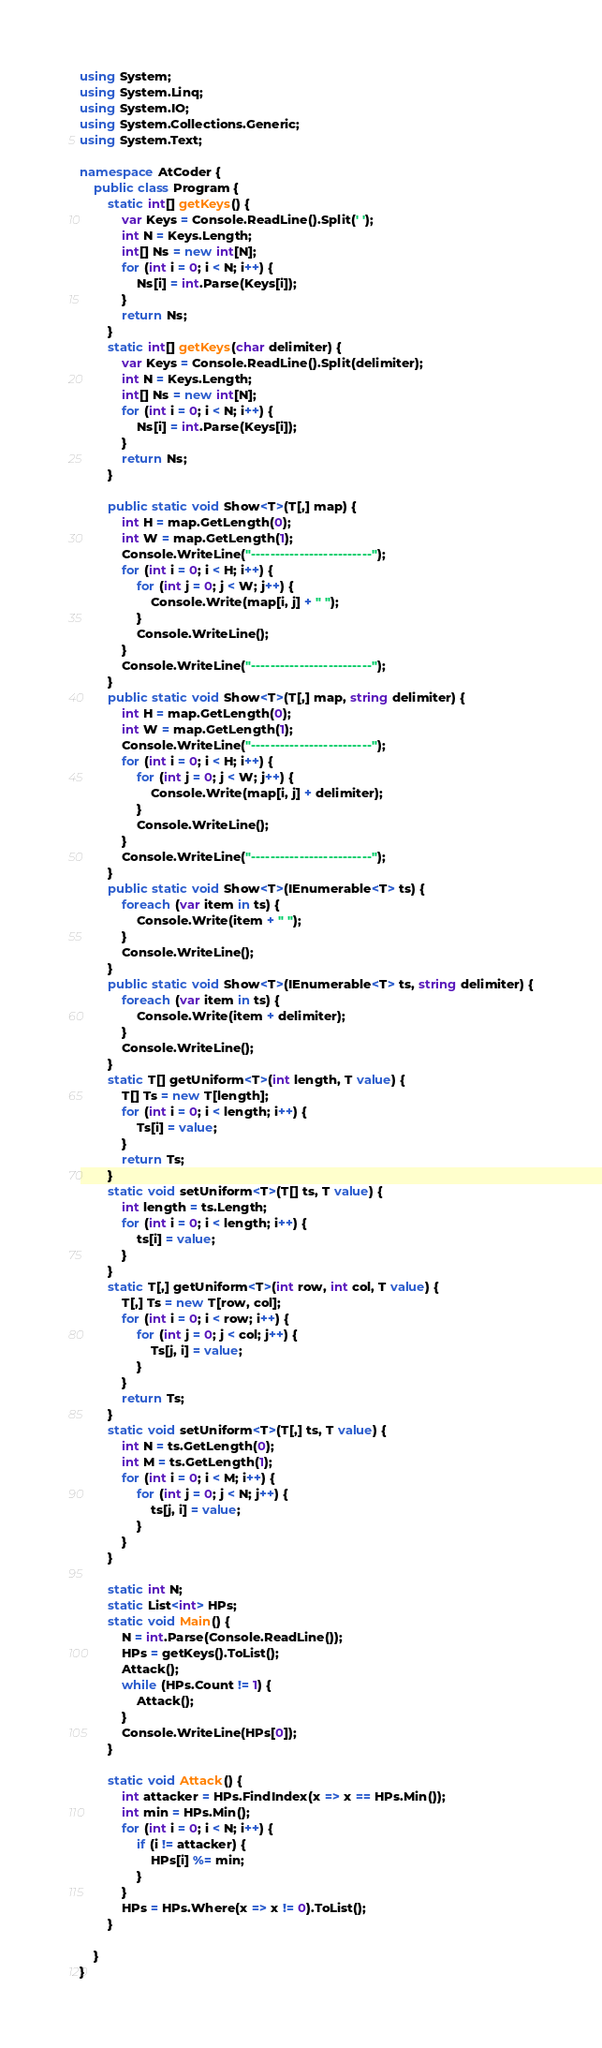<code> <loc_0><loc_0><loc_500><loc_500><_C#_>using System;
using System.Linq;
using System.IO;
using System.Collections.Generic;
using System.Text;

namespace AtCoder {
    public class Program {
        static int[] getKeys() {
            var Keys = Console.ReadLine().Split(' ');
            int N = Keys.Length;
            int[] Ns = new int[N];
            for (int i = 0; i < N; i++) {
                Ns[i] = int.Parse(Keys[i]);
            }
            return Ns;
        }
        static int[] getKeys(char delimiter) {
            var Keys = Console.ReadLine().Split(delimiter);
            int N = Keys.Length;
            int[] Ns = new int[N];
            for (int i = 0; i < N; i++) {
                Ns[i] = int.Parse(Keys[i]);
            }
            return Ns;
        }

        public static void Show<T>(T[,] map) {
            int H = map.GetLength(0);
            int W = map.GetLength(1);
            Console.WriteLine("-------------------------");
            for (int i = 0; i < H; i++) {
                for (int j = 0; j < W; j++) {
                    Console.Write(map[i, j] + " ");
                }
                Console.WriteLine();
            }
            Console.WriteLine("-------------------------");
        }
        public static void Show<T>(T[,] map, string delimiter) {
            int H = map.GetLength(0);
            int W = map.GetLength(1);
            Console.WriteLine("-------------------------");
            for (int i = 0; i < H; i++) {
                for (int j = 0; j < W; j++) {
                    Console.Write(map[i, j] + delimiter);
                }
                Console.WriteLine();
            }
            Console.WriteLine("-------------------------");
        }
        public static void Show<T>(IEnumerable<T> ts) {
            foreach (var item in ts) {
                Console.Write(item + " ");
            }
            Console.WriteLine();
        }
        public static void Show<T>(IEnumerable<T> ts, string delimiter) {
            foreach (var item in ts) {
                Console.Write(item + delimiter);
            }
            Console.WriteLine();
        }
        static T[] getUniform<T>(int length, T value) {
            T[] Ts = new T[length];
            for (int i = 0; i < length; i++) {
                Ts[i] = value;
            }
            return Ts;
        }
        static void setUniform<T>(T[] ts, T value) {
            int length = ts.Length;
            for (int i = 0; i < length; i++) {
                ts[i] = value;
            }
        }
        static T[,] getUniform<T>(int row, int col, T value) {
            T[,] Ts = new T[row, col];
            for (int i = 0; i < row; i++) {
                for (int j = 0; j < col; j++) {
                    Ts[j, i] = value;
                }
            }
            return Ts;
        }
        static void setUniform<T>(T[,] ts, T value) {
            int N = ts.GetLength(0);
            int M = ts.GetLength(1);
            for (int i = 0; i < M; i++) {
                for (int j = 0; j < N; j++) {
                    ts[j, i] = value;
                }
            }
        }

        static int N;
        static List<int> HPs;
        static void Main() {
            N = int.Parse(Console.ReadLine());
            HPs = getKeys().ToList();
            Attack();
            while (HPs.Count != 1) {
                Attack();
            }
            Console.WriteLine(HPs[0]);
        }

        static void Attack() {
            int attacker = HPs.FindIndex(x => x == HPs.Min());
            int min = HPs.Min();
            for (int i = 0; i < N; i++) {
                if (i != attacker) {
                    HPs[i] %= min;
                }
            }
            HPs = HPs.Where(x => x != 0).ToList();
        }

    }
}</code> 